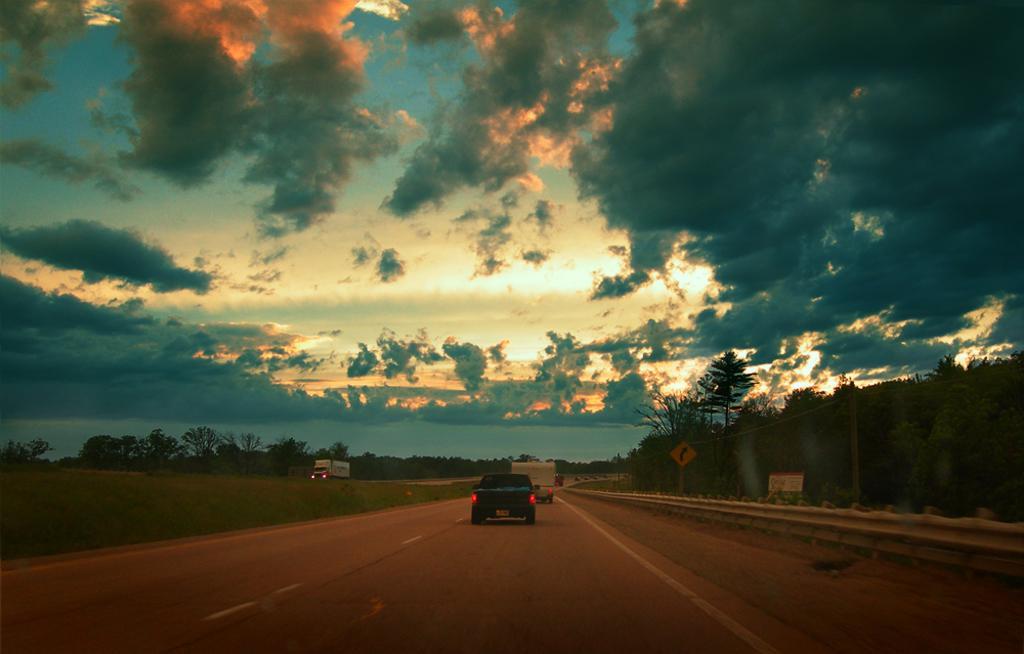Can you describe this image briefly? In this image we can see some vehicles which are moving on road, there are some signage boards, divider, there are some trees on left and right side of the image and top of the image there is cloudy sky and clouds are in blue and orange color. 